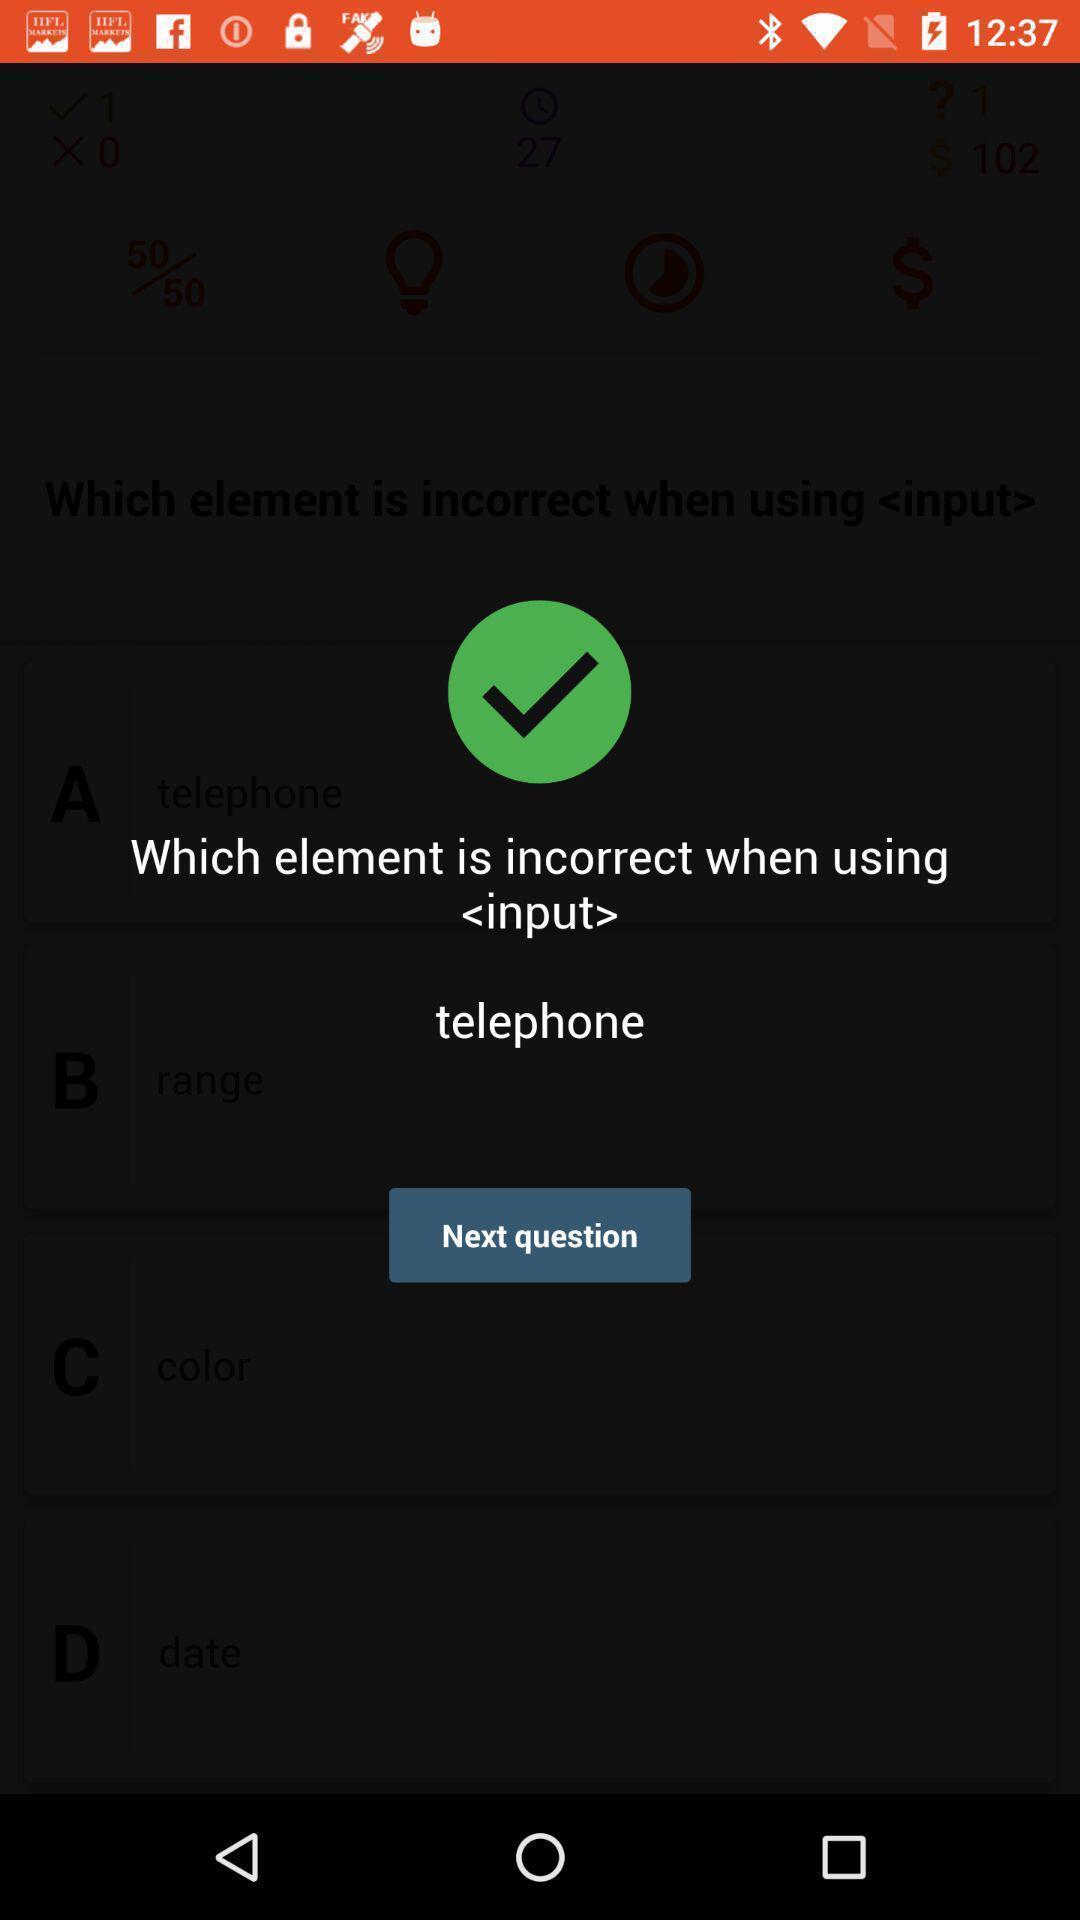What details can you identify in this image? Screen showing the questions of leaning app. 